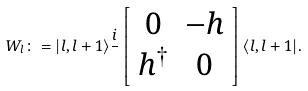<formula> <loc_0><loc_0><loc_500><loc_500>W _ { l } \colon = | l , l + 1 \rangle \frac { i } { } \left [ \begin{array} { c c } 0 & - h \\ h ^ { \dagger } & 0 \end{array} \right ] \langle l , l + 1 | .</formula> 